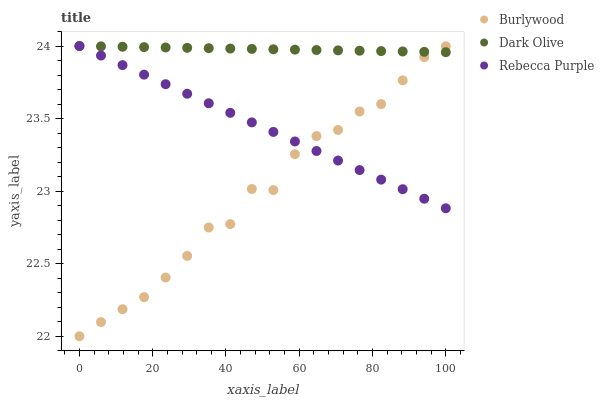Does Burlywood have the minimum area under the curve?
Answer yes or no. Yes. Does Dark Olive have the maximum area under the curve?
Answer yes or no. Yes. Does Rebecca Purple have the minimum area under the curve?
Answer yes or no. No. Does Rebecca Purple have the maximum area under the curve?
Answer yes or no. No. Is Dark Olive the smoothest?
Answer yes or no. Yes. Is Burlywood the roughest?
Answer yes or no. Yes. Is Rebecca Purple the smoothest?
Answer yes or no. No. Is Rebecca Purple the roughest?
Answer yes or no. No. Does Burlywood have the lowest value?
Answer yes or no. Yes. Does Rebecca Purple have the lowest value?
Answer yes or no. No. Does Rebecca Purple have the highest value?
Answer yes or no. Yes. Does Rebecca Purple intersect Burlywood?
Answer yes or no. Yes. Is Rebecca Purple less than Burlywood?
Answer yes or no. No. Is Rebecca Purple greater than Burlywood?
Answer yes or no. No. 